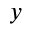<formula> <loc_0><loc_0><loc_500><loc_500>y</formula> 